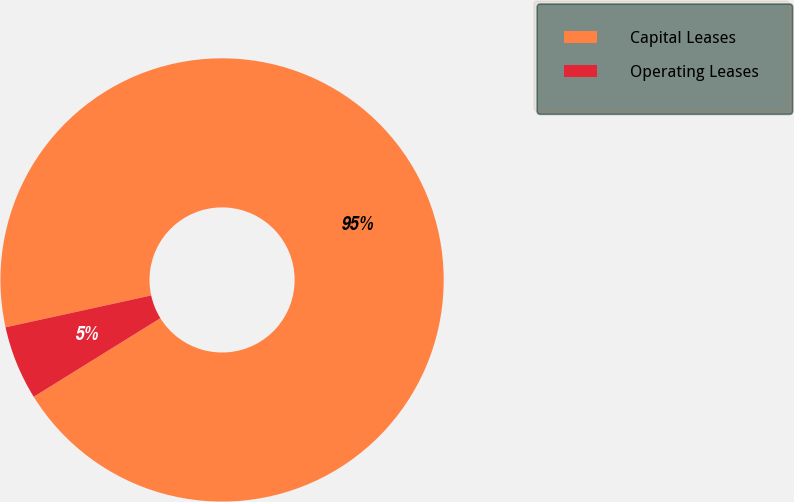Convert chart to OTSL. <chart><loc_0><loc_0><loc_500><loc_500><pie_chart><fcel>Capital Leases<fcel>Operating Leases<nl><fcel>94.59%<fcel>5.41%<nl></chart> 